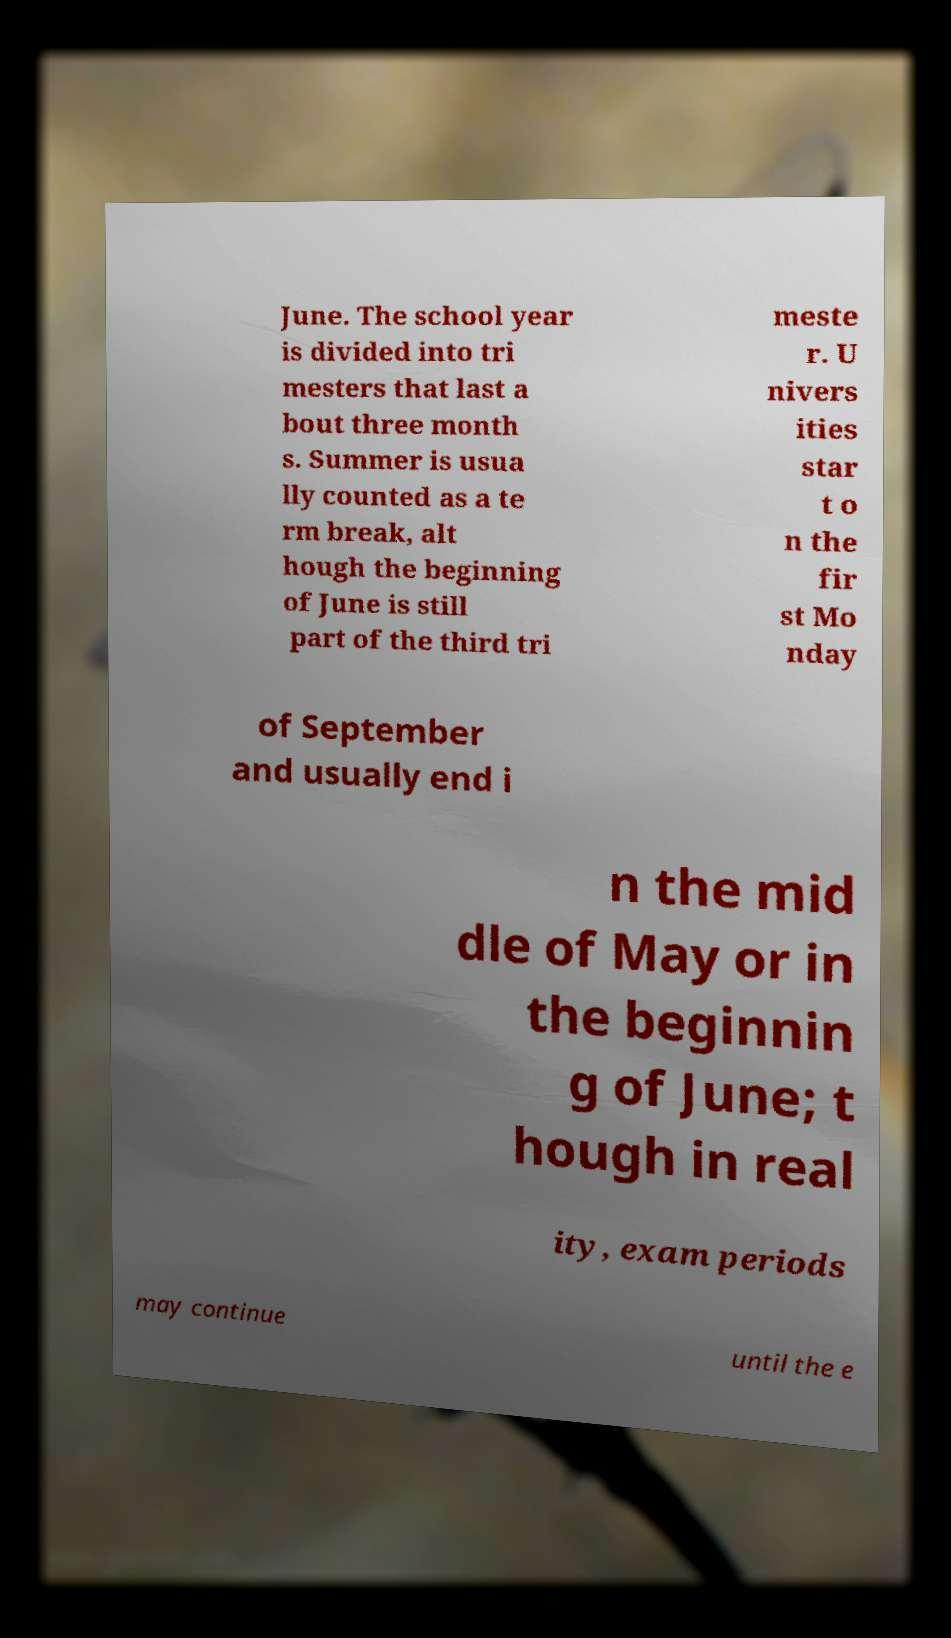Could you assist in decoding the text presented in this image and type it out clearly? June. The school year is divided into tri mesters that last a bout three month s. Summer is usua lly counted as a te rm break, alt hough the beginning of June is still part of the third tri meste r. U nivers ities star t o n the fir st Mo nday of September and usually end i n the mid dle of May or in the beginnin g of June; t hough in real ity, exam periods may continue until the e 